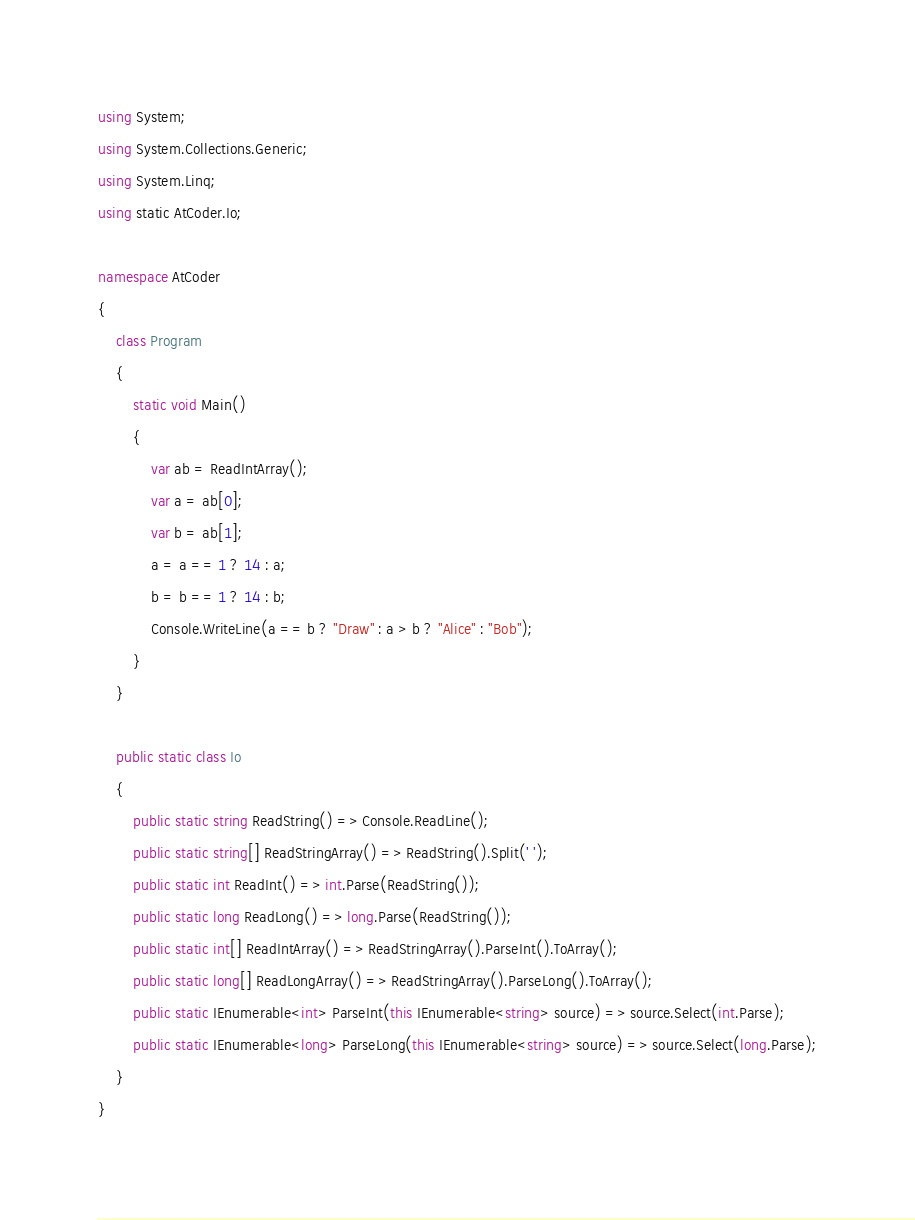Convert code to text. <code><loc_0><loc_0><loc_500><loc_500><_C#_>using System;
using System.Collections.Generic;
using System.Linq;
using static AtCoder.Io;

namespace AtCoder
{
    class Program
    {
        static void Main()
        {
            var ab = ReadIntArray();
            var a = ab[0];
            var b = ab[1];
            a = a == 1 ? 14 : a;
            b = b == 1 ? 14 : b;
            Console.WriteLine(a == b ? "Draw" : a > b ? "Alice" : "Bob");
        }
    }

    public static class Io
    {
        public static string ReadString() => Console.ReadLine();
        public static string[] ReadStringArray() => ReadString().Split(' ');
        public static int ReadInt() => int.Parse(ReadString());
        public static long ReadLong() => long.Parse(ReadString());
        public static int[] ReadIntArray() => ReadStringArray().ParseInt().ToArray();
        public static long[] ReadLongArray() => ReadStringArray().ParseLong().ToArray();
        public static IEnumerable<int> ParseInt(this IEnumerable<string> source) => source.Select(int.Parse);
        public static IEnumerable<long> ParseLong(this IEnumerable<string> source) => source.Select(long.Parse);
    }
}
</code> 